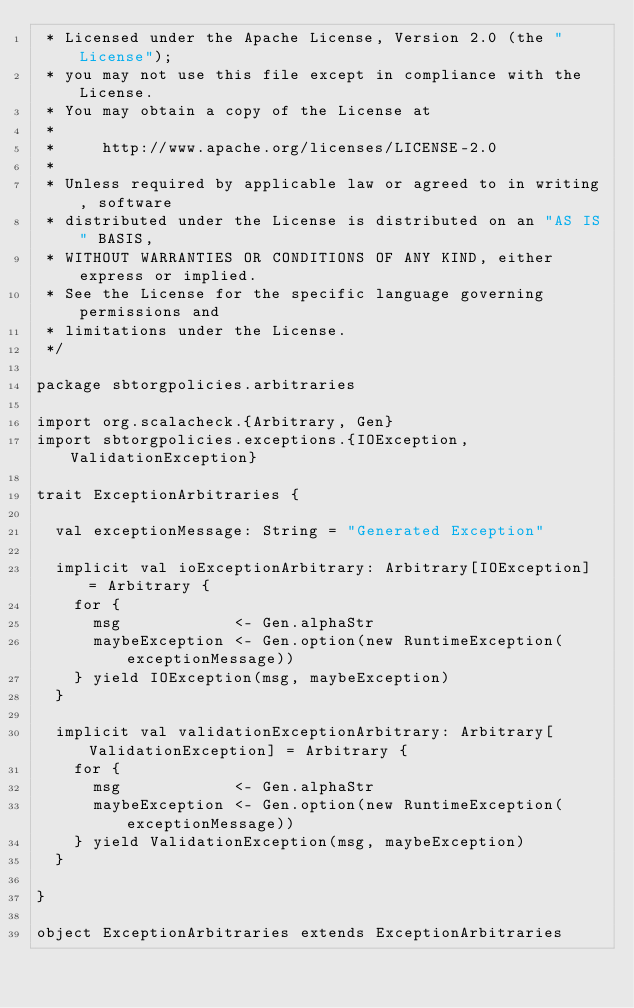Convert code to text. <code><loc_0><loc_0><loc_500><loc_500><_Scala_> * Licensed under the Apache License, Version 2.0 (the "License");
 * you may not use this file except in compliance with the License.
 * You may obtain a copy of the License at
 *
 *     http://www.apache.org/licenses/LICENSE-2.0
 *
 * Unless required by applicable law or agreed to in writing, software
 * distributed under the License is distributed on an "AS IS" BASIS,
 * WITHOUT WARRANTIES OR CONDITIONS OF ANY KIND, either express or implied.
 * See the License for the specific language governing permissions and
 * limitations under the License.
 */

package sbtorgpolicies.arbitraries

import org.scalacheck.{Arbitrary, Gen}
import sbtorgpolicies.exceptions.{IOException, ValidationException}

trait ExceptionArbitraries {

  val exceptionMessage: String = "Generated Exception"

  implicit val ioExceptionArbitrary: Arbitrary[IOException] = Arbitrary {
    for {
      msg            <- Gen.alphaStr
      maybeException <- Gen.option(new RuntimeException(exceptionMessage))
    } yield IOException(msg, maybeException)
  }

  implicit val validationExceptionArbitrary: Arbitrary[ValidationException] = Arbitrary {
    for {
      msg            <- Gen.alphaStr
      maybeException <- Gen.option(new RuntimeException(exceptionMessage))
    } yield ValidationException(msg, maybeException)
  }

}

object ExceptionArbitraries extends ExceptionArbitraries
</code> 